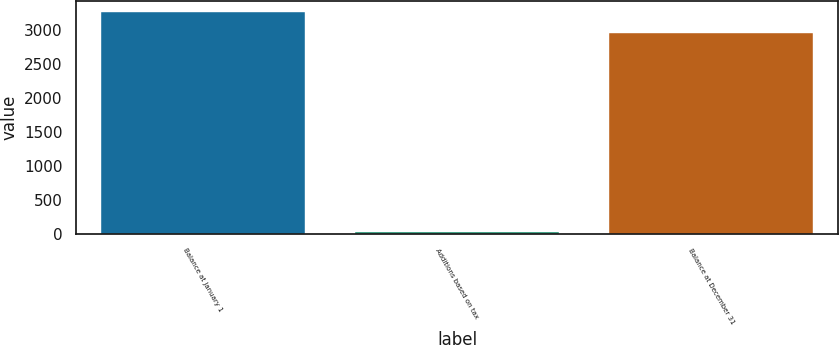Convert chart to OTSL. <chart><loc_0><loc_0><loc_500><loc_500><bar_chart><fcel>Balance at January 1<fcel>Additions based on tax<fcel>Balance at December 31<nl><fcel>3273.2<fcel>36<fcel>2965<nl></chart> 